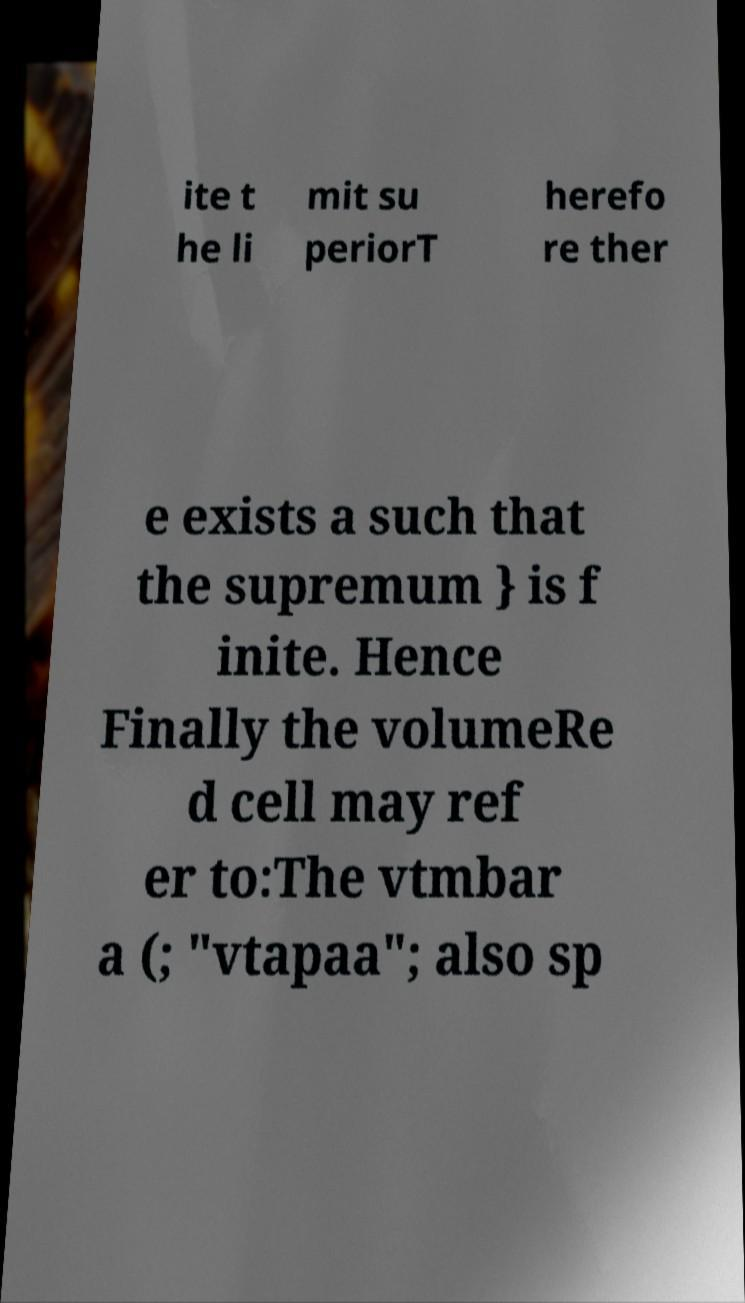There's text embedded in this image that I need extracted. Can you transcribe it verbatim? ite t he li mit su periorT herefo re ther e exists a such that the supremum } is f inite. Hence Finally the volumeRe d cell may ref er to:The vtmbar a (; "vtapaa"; also sp 